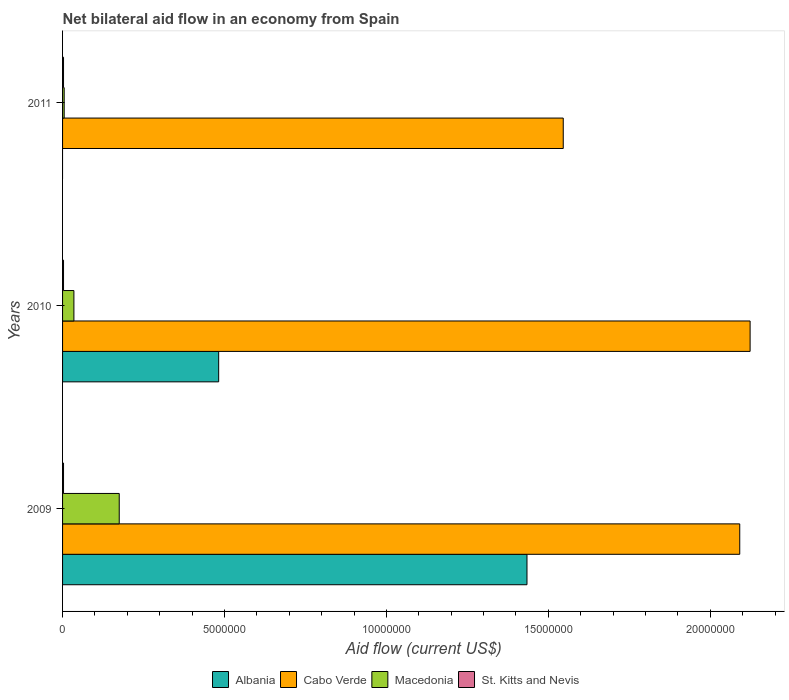How many different coloured bars are there?
Offer a very short reply. 4. Are the number of bars per tick equal to the number of legend labels?
Offer a very short reply. No. Are the number of bars on each tick of the Y-axis equal?
Provide a short and direct response. No. What is the net bilateral aid flow in Macedonia in 2010?
Provide a short and direct response. 3.50e+05. Across all years, what is the maximum net bilateral aid flow in Macedonia?
Make the answer very short. 1.75e+06. What is the total net bilateral aid flow in Cabo Verde in the graph?
Ensure brevity in your answer.  5.76e+07. What is the difference between the net bilateral aid flow in Albania in 2009 and that in 2010?
Keep it short and to the point. 9.52e+06. What is the difference between the net bilateral aid flow in Cabo Verde in 2010 and the net bilateral aid flow in Macedonia in 2009?
Keep it short and to the point. 1.95e+07. What is the average net bilateral aid flow in Macedonia per year?
Give a very brief answer. 7.17e+05. In how many years, is the net bilateral aid flow in Albania greater than 13000000 US$?
Your answer should be very brief. 1. Is the net bilateral aid flow in St. Kitts and Nevis in 2010 less than that in 2011?
Ensure brevity in your answer.  No. In how many years, is the net bilateral aid flow in Albania greater than the average net bilateral aid flow in Albania taken over all years?
Provide a succinct answer. 1. Is the sum of the net bilateral aid flow in St. Kitts and Nevis in 2009 and 2010 greater than the maximum net bilateral aid flow in Macedonia across all years?
Offer a very short reply. No. How many bars are there?
Give a very brief answer. 11. Are all the bars in the graph horizontal?
Keep it short and to the point. Yes. How many years are there in the graph?
Provide a short and direct response. 3. Are the values on the major ticks of X-axis written in scientific E-notation?
Give a very brief answer. No. Does the graph contain any zero values?
Offer a terse response. Yes. Does the graph contain grids?
Your answer should be very brief. No. How many legend labels are there?
Your response must be concise. 4. How are the legend labels stacked?
Your response must be concise. Horizontal. What is the title of the graph?
Your response must be concise. Net bilateral aid flow in an economy from Spain. What is the Aid flow (current US$) of Albania in 2009?
Offer a terse response. 1.43e+07. What is the Aid flow (current US$) in Cabo Verde in 2009?
Offer a very short reply. 2.09e+07. What is the Aid flow (current US$) in Macedonia in 2009?
Offer a very short reply. 1.75e+06. What is the Aid flow (current US$) in St. Kitts and Nevis in 2009?
Your answer should be compact. 3.00e+04. What is the Aid flow (current US$) of Albania in 2010?
Make the answer very short. 4.82e+06. What is the Aid flow (current US$) of Cabo Verde in 2010?
Ensure brevity in your answer.  2.12e+07. What is the Aid flow (current US$) in St. Kitts and Nevis in 2010?
Your response must be concise. 3.00e+04. What is the Aid flow (current US$) in Albania in 2011?
Offer a very short reply. 0. What is the Aid flow (current US$) of Cabo Verde in 2011?
Offer a terse response. 1.55e+07. What is the Aid flow (current US$) of Macedonia in 2011?
Your answer should be compact. 5.00e+04. Across all years, what is the maximum Aid flow (current US$) of Albania?
Your answer should be very brief. 1.43e+07. Across all years, what is the maximum Aid flow (current US$) in Cabo Verde?
Your answer should be compact. 2.12e+07. Across all years, what is the maximum Aid flow (current US$) of Macedonia?
Provide a succinct answer. 1.75e+06. Across all years, what is the minimum Aid flow (current US$) of Cabo Verde?
Provide a short and direct response. 1.55e+07. What is the total Aid flow (current US$) in Albania in the graph?
Give a very brief answer. 1.92e+07. What is the total Aid flow (current US$) of Cabo Verde in the graph?
Your answer should be compact. 5.76e+07. What is the total Aid flow (current US$) of Macedonia in the graph?
Offer a terse response. 2.15e+06. What is the difference between the Aid flow (current US$) in Albania in 2009 and that in 2010?
Offer a terse response. 9.52e+06. What is the difference between the Aid flow (current US$) of Cabo Verde in 2009 and that in 2010?
Provide a succinct answer. -3.20e+05. What is the difference between the Aid flow (current US$) of Macedonia in 2009 and that in 2010?
Provide a short and direct response. 1.40e+06. What is the difference between the Aid flow (current US$) of Cabo Verde in 2009 and that in 2011?
Your response must be concise. 5.45e+06. What is the difference between the Aid flow (current US$) of Macedonia in 2009 and that in 2011?
Give a very brief answer. 1.70e+06. What is the difference between the Aid flow (current US$) in St. Kitts and Nevis in 2009 and that in 2011?
Make the answer very short. 0. What is the difference between the Aid flow (current US$) in Cabo Verde in 2010 and that in 2011?
Provide a succinct answer. 5.77e+06. What is the difference between the Aid flow (current US$) of Macedonia in 2010 and that in 2011?
Your answer should be compact. 3.00e+05. What is the difference between the Aid flow (current US$) in Albania in 2009 and the Aid flow (current US$) in Cabo Verde in 2010?
Your response must be concise. -6.89e+06. What is the difference between the Aid flow (current US$) in Albania in 2009 and the Aid flow (current US$) in Macedonia in 2010?
Keep it short and to the point. 1.40e+07. What is the difference between the Aid flow (current US$) of Albania in 2009 and the Aid flow (current US$) of St. Kitts and Nevis in 2010?
Provide a short and direct response. 1.43e+07. What is the difference between the Aid flow (current US$) of Cabo Verde in 2009 and the Aid flow (current US$) of Macedonia in 2010?
Ensure brevity in your answer.  2.06e+07. What is the difference between the Aid flow (current US$) of Cabo Verde in 2009 and the Aid flow (current US$) of St. Kitts and Nevis in 2010?
Offer a terse response. 2.09e+07. What is the difference between the Aid flow (current US$) of Macedonia in 2009 and the Aid flow (current US$) of St. Kitts and Nevis in 2010?
Provide a short and direct response. 1.72e+06. What is the difference between the Aid flow (current US$) in Albania in 2009 and the Aid flow (current US$) in Cabo Verde in 2011?
Give a very brief answer. -1.12e+06. What is the difference between the Aid flow (current US$) in Albania in 2009 and the Aid flow (current US$) in Macedonia in 2011?
Your answer should be compact. 1.43e+07. What is the difference between the Aid flow (current US$) of Albania in 2009 and the Aid flow (current US$) of St. Kitts and Nevis in 2011?
Ensure brevity in your answer.  1.43e+07. What is the difference between the Aid flow (current US$) of Cabo Verde in 2009 and the Aid flow (current US$) of Macedonia in 2011?
Offer a very short reply. 2.09e+07. What is the difference between the Aid flow (current US$) of Cabo Verde in 2009 and the Aid flow (current US$) of St. Kitts and Nevis in 2011?
Your answer should be very brief. 2.09e+07. What is the difference between the Aid flow (current US$) of Macedonia in 2009 and the Aid flow (current US$) of St. Kitts and Nevis in 2011?
Give a very brief answer. 1.72e+06. What is the difference between the Aid flow (current US$) of Albania in 2010 and the Aid flow (current US$) of Cabo Verde in 2011?
Provide a short and direct response. -1.06e+07. What is the difference between the Aid flow (current US$) in Albania in 2010 and the Aid flow (current US$) in Macedonia in 2011?
Your answer should be very brief. 4.77e+06. What is the difference between the Aid flow (current US$) of Albania in 2010 and the Aid flow (current US$) of St. Kitts and Nevis in 2011?
Provide a short and direct response. 4.79e+06. What is the difference between the Aid flow (current US$) of Cabo Verde in 2010 and the Aid flow (current US$) of Macedonia in 2011?
Your response must be concise. 2.12e+07. What is the difference between the Aid flow (current US$) of Cabo Verde in 2010 and the Aid flow (current US$) of St. Kitts and Nevis in 2011?
Your response must be concise. 2.12e+07. What is the average Aid flow (current US$) in Albania per year?
Your answer should be very brief. 6.39e+06. What is the average Aid flow (current US$) in Cabo Verde per year?
Provide a short and direct response. 1.92e+07. What is the average Aid flow (current US$) in Macedonia per year?
Your answer should be compact. 7.17e+05. In the year 2009, what is the difference between the Aid flow (current US$) in Albania and Aid flow (current US$) in Cabo Verde?
Offer a terse response. -6.57e+06. In the year 2009, what is the difference between the Aid flow (current US$) of Albania and Aid flow (current US$) of Macedonia?
Your response must be concise. 1.26e+07. In the year 2009, what is the difference between the Aid flow (current US$) of Albania and Aid flow (current US$) of St. Kitts and Nevis?
Offer a terse response. 1.43e+07. In the year 2009, what is the difference between the Aid flow (current US$) of Cabo Verde and Aid flow (current US$) of Macedonia?
Keep it short and to the point. 1.92e+07. In the year 2009, what is the difference between the Aid flow (current US$) of Cabo Verde and Aid flow (current US$) of St. Kitts and Nevis?
Offer a terse response. 2.09e+07. In the year 2009, what is the difference between the Aid flow (current US$) of Macedonia and Aid flow (current US$) of St. Kitts and Nevis?
Give a very brief answer. 1.72e+06. In the year 2010, what is the difference between the Aid flow (current US$) of Albania and Aid flow (current US$) of Cabo Verde?
Provide a short and direct response. -1.64e+07. In the year 2010, what is the difference between the Aid flow (current US$) in Albania and Aid flow (current US$) in Macedonia?
Your response must be concise. 4.47e+06. In the year 2010, what is the difference between the Aid flow (current US$) of Albania and Aid flow (current US$) of St. Kitts and Nevis?
Your response must be concise. 4.79e+06. In the year 2010, what is the difference between the Aid flow (current US$) of Cabo Verde and Aid flow (current US$) of Macedonia?
Your answer should be compact. 2.09e+07. In the year 2010, what is the difference between the Aid flow (current US$) in Cabo Verde and Aid flow (current US$) in St. Kitts and Nevis?
Provide a succinct answer. 2.12e+07. In the year 2011, what is the difference between the Aid flow (current US$) in Cabo Verde and Aid flow (current US$) in Macedonia?
Your answer should be compact. 1.54e+07. In the year 2011, what is the difference between the Aid flow (current US$) in Cabo Verde and Aid flow (current US$) in St. Kitts and Nevis?
Offer a very short reply. 1.54e+07. What is the ratio of the Aid flow (current US$) in Albania in 2009 to that in 2010?
Give a very brief answer. 2.98. What is the ratio of the Aid flow (current US$) in Cabo Verde in 2009 to that in 2010?
Give a very brief answer. 0.98. What is the ratio of the Aid flow (current US$) of St. Kitts and Nevis in 2009 to that in 2010?
Make the answer very short. 1. What is the ratio of the Aid flow (current US$) of Cabo Verde in 2009 to that in 2011?
Provide a succinct answer. 1.35. What is the ratio of the Aid flow (current US$) of Macedonia in 2009 to that in 2011?
Offer a terse response. 35. What is the ratio of the Aid flow (current US$) in St. Kitts and Nevis in 2009 to that in 2011?
Your response must be concise. 1. What is the ratio of the Aid flow (current US$) in Cabo Verde in 2010 to that in 2011?
Ensure brevity in your answer.  1.37. What is the ratio of the Aid flow (current US$) of Macedonia in 2010 to that in 2011?
Your response must be concise. 7. What is the ratio of the Aid flow (current US$) in St. Kitts and Nevis in 2010 to that in 2011?
Your response must be concise. 1. What is the difference between the highest and the second highest Aid flow (current US$) in Macedonia?
Offer a terse response. 1.40e+06. What is the difference between the highest and the second highest Aid flow (current US$) of St. Kitts and Nevis?
Offer a very short reply. 0. What is the difference between the highest and the lowest Aid flow (current US$) in Albania?
Your response must be concise. 1.43e+07. What is the difference between the highest and the lowest Aid flow (current US$) in Cabo Verde?
Ensure brevity in your answer.  5.77e+06. What is the difference between the highest and the lowest Aid flow (current US$) of Macedonia?
Provide a short and direct response. 1.70e+06. 